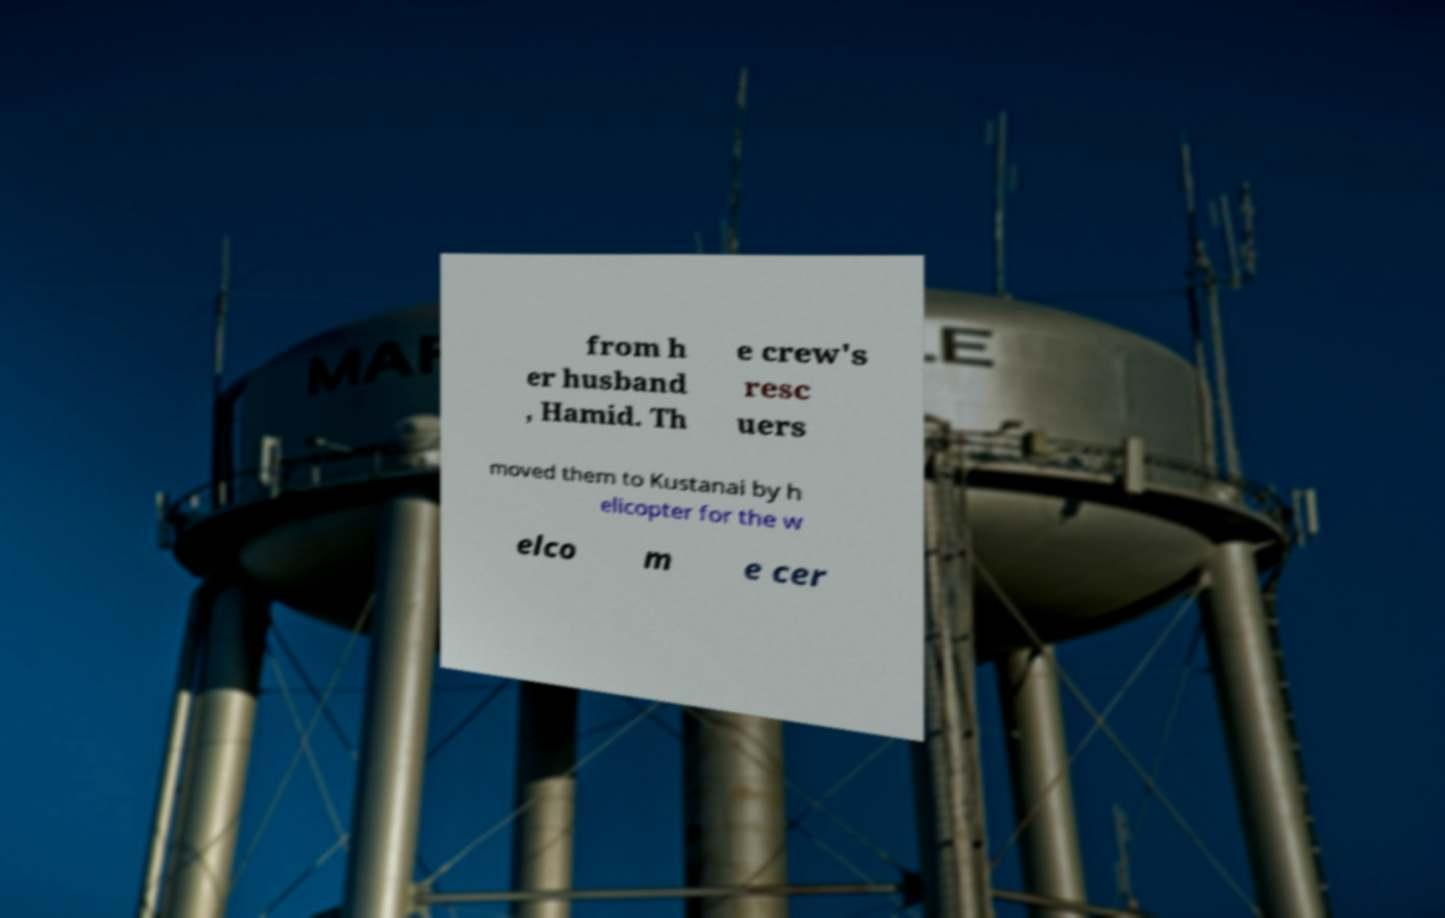Can you read and provide the text displayed in the image?This photo seems to have some interesting text. Can you extract and type it out for me? from h er husband , Hamid. Th e crew's resc uers moved them to Kustanai by h elicopter for the w elco m e cer 